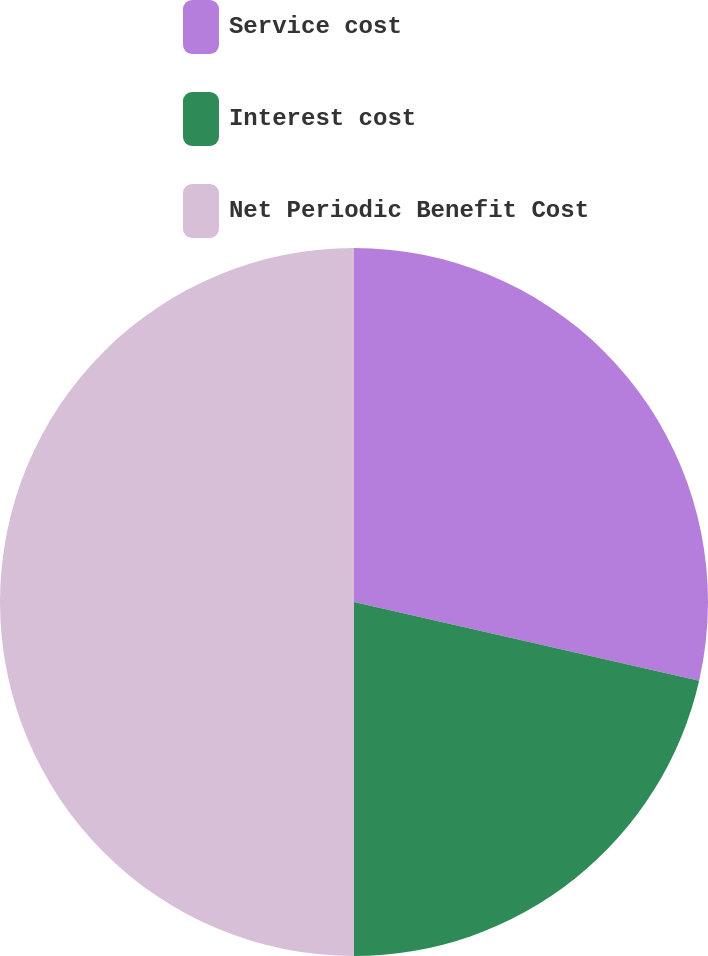<chart> <loc_0><loc_0><loc_500><loc_500><pie_chart><fcel>Service cost<fcel>Interest cost<fcel>Net Periodic Benefit Cost<nl><fcel>28.57%<fcel>21.43%<fcel>50.0%<nl></chart> 